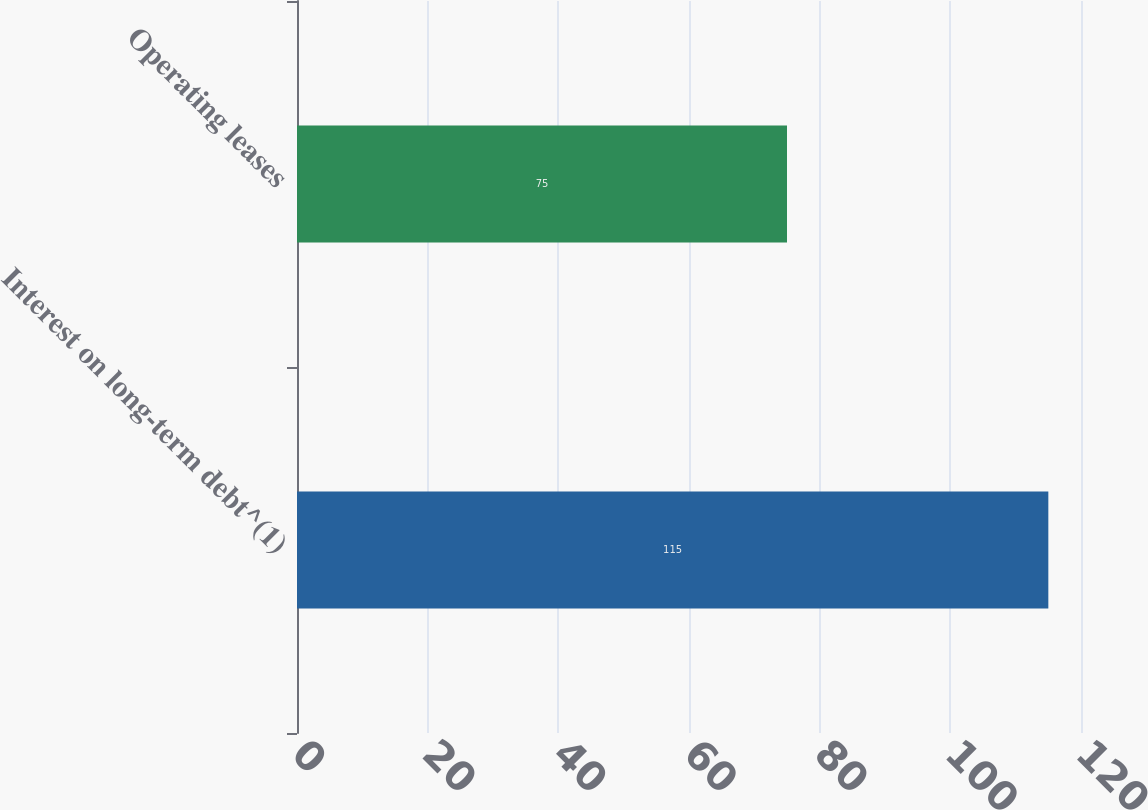<chart> <loc_0><loc_0><loc_500><loc_500><bar_chart><fcel>Interest on long-term debt^(1)<fcel>Operating leases<nl><fcel>115<fcel>75<nl></chart> 